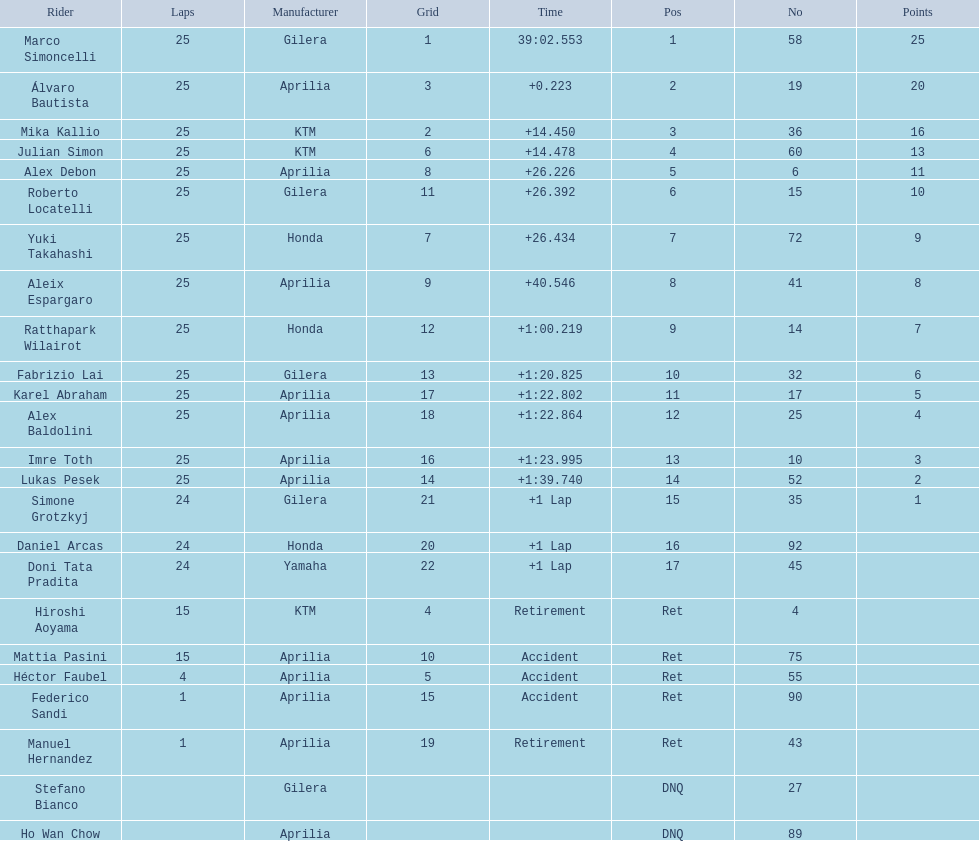What was the fastest overall time? 39:02.553. Who does this time belong to? Marco Simoncelli. 